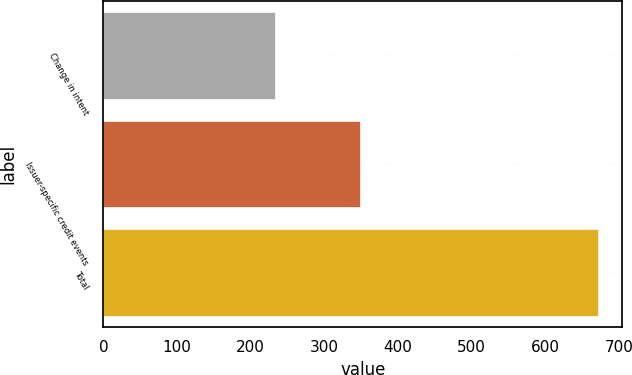Convert chart. <chart><loc_0><loc_0><loc_500><loc_500><bar_chart><fcel>Change in intent<fcel>Issuer-specific credit events<fcel>Total<nl><fcel>233<fcel>348<fcel>671<nl></chart> 